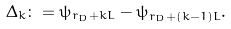Convert formula to latex. <formula><loc_0><loc_0><loc_500><loc_500>\Delta _ { k } \colon = \psi _ { r _ { D } + k L } - \psi _ { r _ { D } + ( k - 1 ) L } .</formula> 